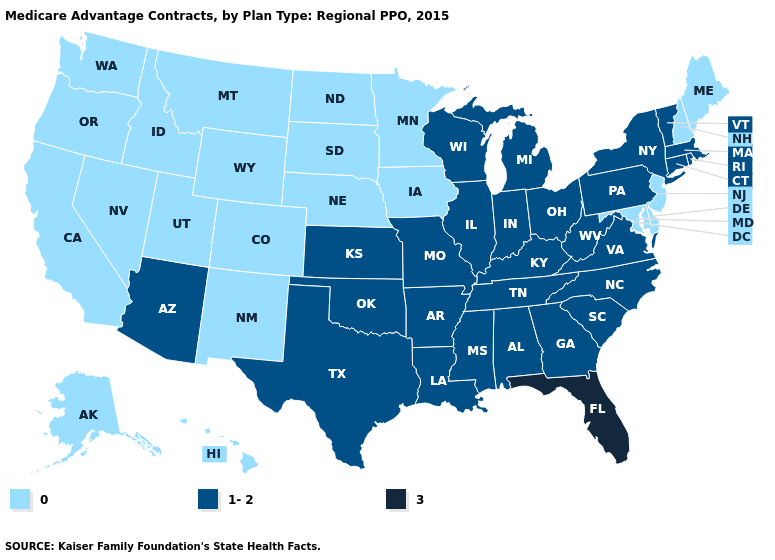Name the states that have a value in the range 3?
Concise answer only. Florida. Name the states that have a value in the range 0?
Answer briefly. Alaska, California, Colorado, Delaware, Hawaii, Iowa, Idaho, Maryland, Maine, Minnesota, Montana, North Dakota, Nebraska, New Hampshire, New Jersey, New Mexico, Nevada, Oregon, South Dakota, Utah, Washington, Wyoming. Name the states that have a value in the range 1-2?
Give a very brief answer. Alabama, Arkansas, Arizona, Connecticut, Georgia, Illinois, Indiana, Kansas, Kentucky, Louisiana, Massachusetts, Michigan, Missouri, Mississippi, North Carolina, New York, Ohio, Oklahoma, Pennsylvania, Rhode Island, South Carolina, Tennessee, Texas, Virginia, Vermont, Wisconsin, West Virginia. What is the lowest value in states that border Pennsylvania?
Write a very short answer. 0. Name the states that have a value in the range 1-2?
Quick response, please. Alabama, Arkansas, Arizona, Connecticut, Georgia, Illinois, Indiana, Kansas, Kentucky, Louisiana, Massachusetts, Michigan, Missouri, Mississippi, North Carolina, New York, Ohio, Oklahoma, Pennsylvania, Rhode Island, South Carolina, Tennessee, Texas, Virginia, Vermont, Wisconsin, West Virginia. Name the states that have a value in the range 1-2?
Be succinct. Alabama, Arkansas, Arizona, Connecticut, Georgia, Illinois, Indiana, Kansas, Kentucky, Louisiana, Massachusetts, Michigan, Missouri, Mississippi, North Carolina, New York, Ohio, Oklahoma, Pennsylvania, Rhode Island, South Carolina, Tennessee, Texas, Virginia, Vermont, Wisconsin, West Virginia. Name the states that have a value in the range 1-2?
Give a very brief answer. Alabama, Arkansas, Arizona, Connecticut, Georgia, Illinois, Indiana, Kansas, Kentucky, Louisiana, Massachusetts, Michigan, Missouri, Mississippi, North Carolina, New York, Ohio, Oklahoma, Pennsylvania, Rhode Island, South Carolina, Tennessee, Texas, Virginia, Vermont, Wisconsin, West Virginia. What is the lowest value in the West?
Short answer required. 0. Name the states that have a value in the range 1-2?
Be succinct. Alabama, Arkansas, Arizona, Connecticut, Georgia, Illinois, Indiana, Kansas, Kentucky, Louisiana, Massachusetts, Michigan, Missouri, Mississippi, North Carolina, New York, Ohio, Oklahoma, Pennsylvania, Rhode Island, South Carolina, Tennessee, Texas, Virginia, Vermont, Wisconsin, West Virginia. What is the highest value in states that border Arkansas?
Write a very short answer. 1-2. Among the states that border Idaho , which have the lowest value?
Keep it brief. Montana, Nevada, Oregon, Utah, Washington, Wyoming. Does Rhode Island have the highest value in the Northeast?
Answer briefly. Yes. What is the value of Texas?
Quick response, please. 1-2. Does Delaware have the highest value in the South?
Short answer required. No. Name the states that have a value in the range 1-2?
Quick response, please. Alabama, Arkansas, Arizona, Connecticut, Georgia, Illinois, Indiana, Kansas, Kentucky, Louisiana, Massachusetts, Michigan, Missouri, Mississippi, North Carolina, New York, Ohio, Oklahoma, Pennsylvania, Rhode Island, South Carolina, Tennessee, Texas, Virginia, Vermont, Wisconsin, West Virginia. 